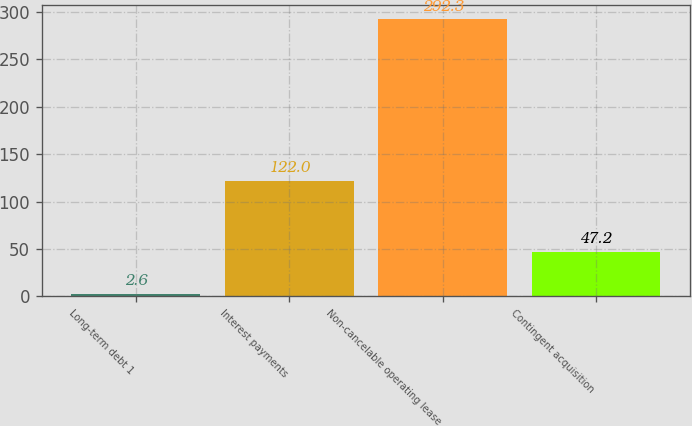Convert chart. <chart><loc_0><loc_0><loc_500><loc_500><bar_chart><fcel>Long-term debt 1<fcel>Interest payments<fcel>Non-cancelable operating lease<fcel>Contingent acquisition<nl><fcel>2.6<fcel>122<fcel>292.3<fcel>47.2<nl></chart> 